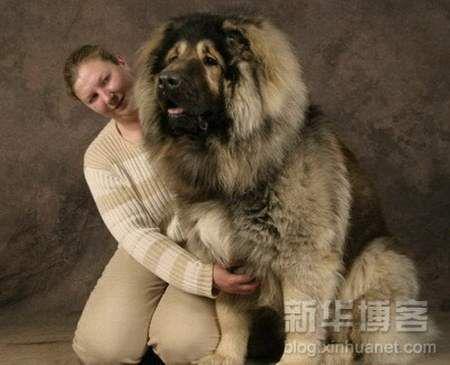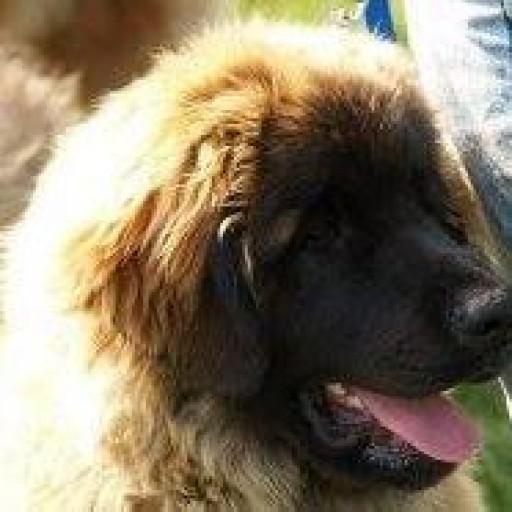The first image is the image on the left, the second image is the image on the right. Assess this claim about the two images: "The left image includes a human interacting with a large dog.". Correct or not? Answer yes or no. Yes. The first image is the image on the left, the second image is the image on the right. Examine the images to the left and right. Is the description "In one image, a kneeling woman's head is nearly even with that of the large dog she poses next to." accurate? Answer yes or no. Yes. 